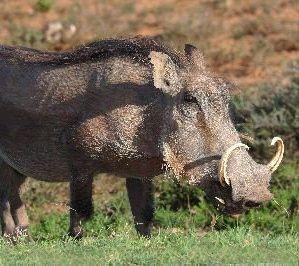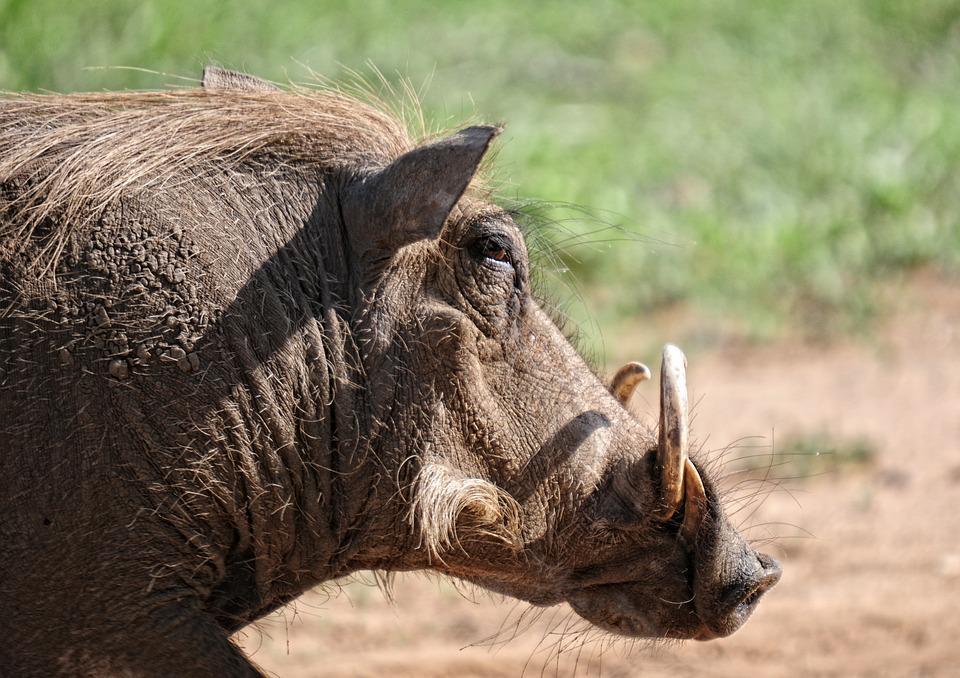The first image is the image on the left, the second image is the image on the right. For the images displayed, is the sentence "The image on the left contains exactly two animals." factually correct? Answer yes or no. No. 